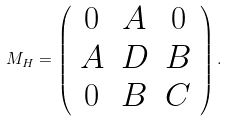<formula> <loc_0><loc_0><loc_500><loc_500>M _ { H } = \left ( \begin{array} { c c c } 0 & A & 0 \\ A & D & B \\ 0 & B & C \end{array} \right ) .</formula> 